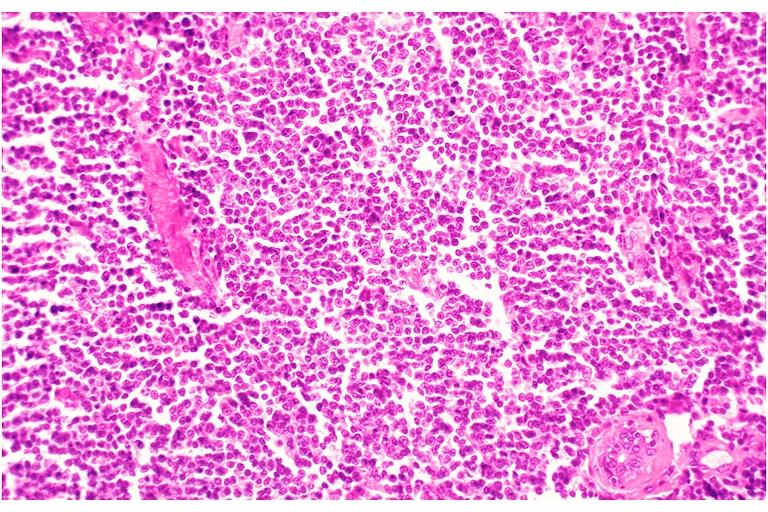s oral present?
Answer the question using a single word or phrase. Yes 